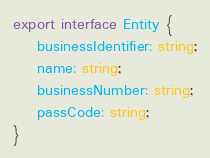<code> <loc_0><loc_0><loc_500><loc_500><_TypeScript_>export interface Entity {
    businessIdentifier: string;
    name: string;
    businessNumber: string;
    passCode: string;
}
</code> 